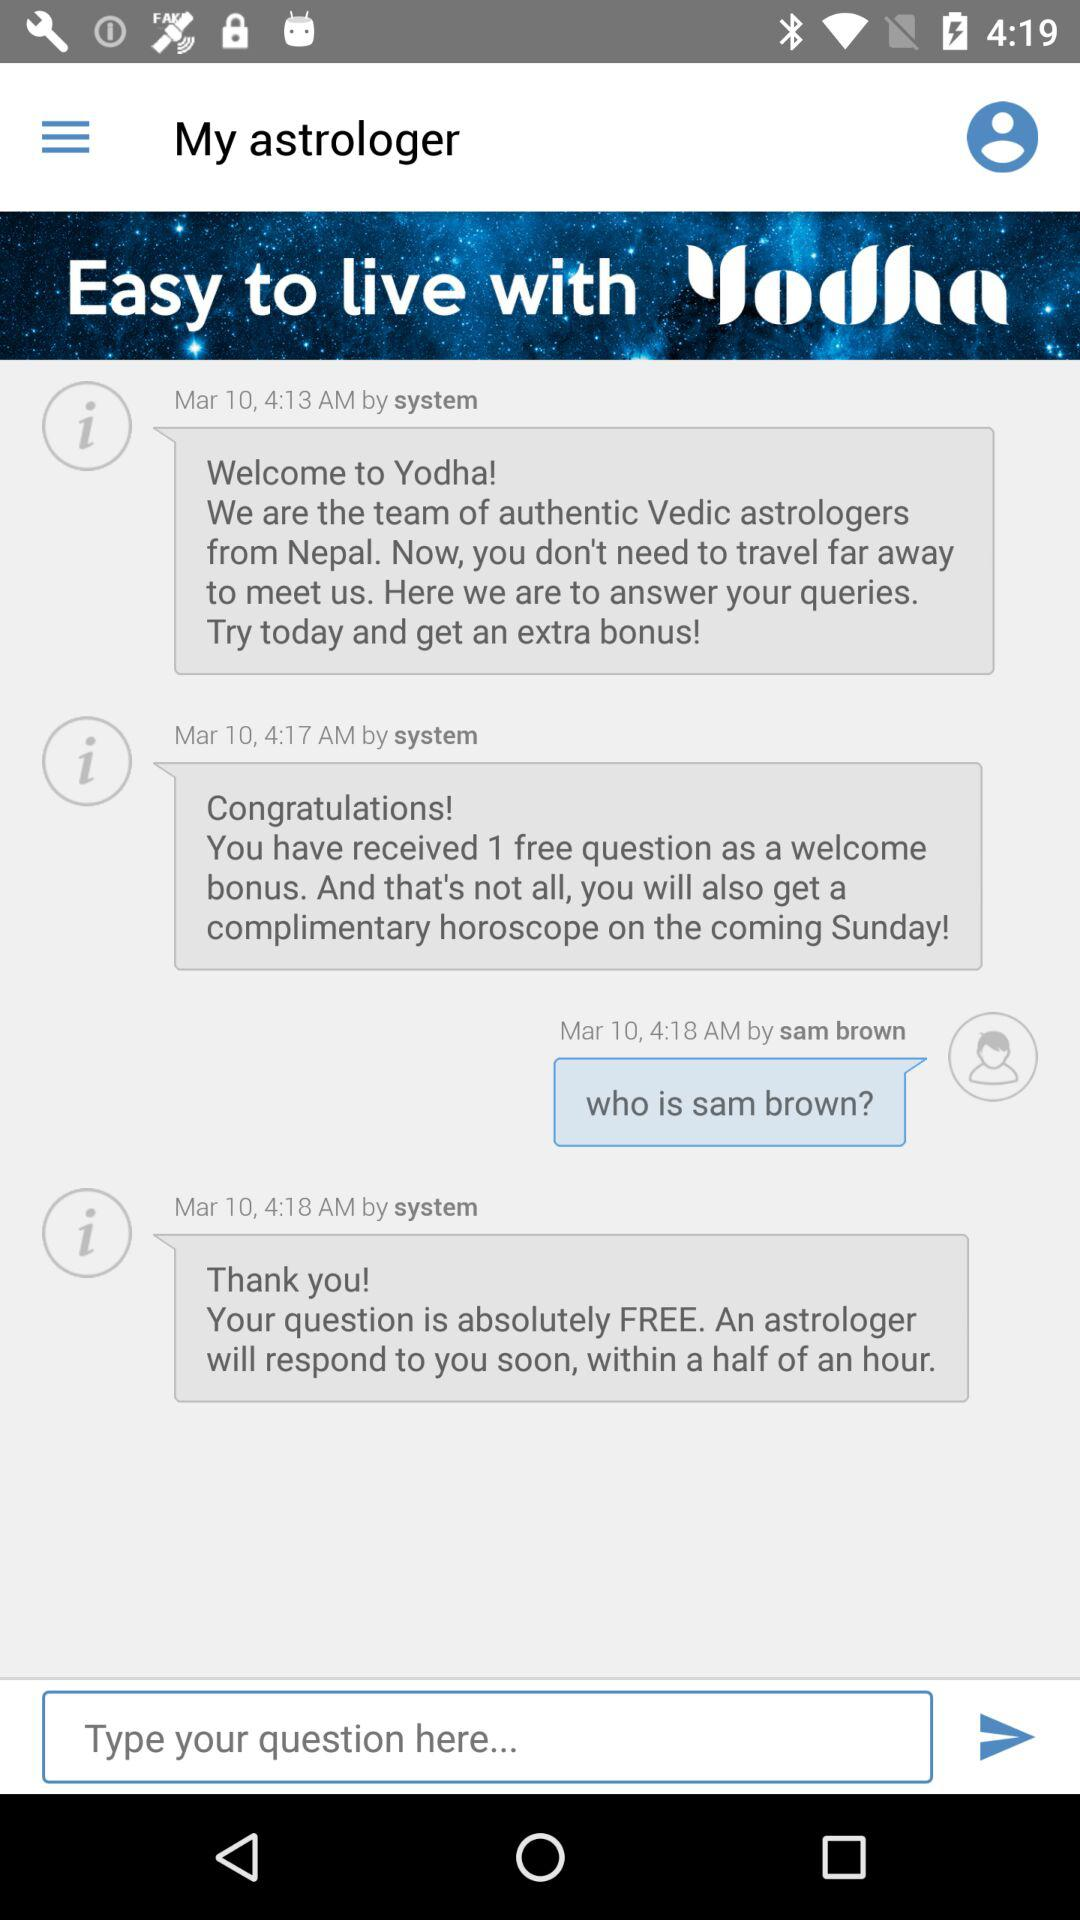What day was on February 13, 1990? The day was Tuesday. 